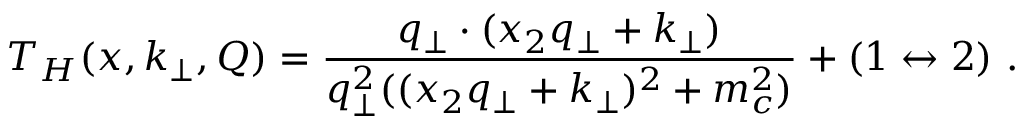Convert formula to latex. <formula><loc_0><loc_0><loc_500><loc_500>T _ { H } ( x , k _ { \perp } , Q ) = \frac { q _ { \perp } \cdot ( x _ { 2 } q _ { \perp } + k _ { \perp } ) } { q _ { \perp } ^ { 2 } ( ( x _ { 2 } q _ { \perp } + k _ { \perp } ) ^ { 2 } + m _ { c } ^ { 2 } ) } + ( 1 \leftrightarrow 2 ) \ .</formula> 